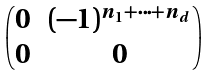Convert formula to latex. <formula><loc_0><loc_0><loc_500><loc_500>\begin{pmatrix} 0 & ( - 1 ) ^ { n _ { 1 } + \dots + n _ { d } } \\ 0 & 0 \end{pmatrix}</formula> 